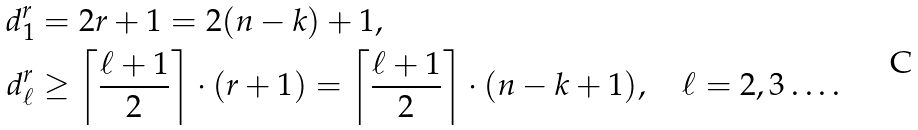<formula> <loc_0><loc_0><loc_500><loc_500>d ^ { r } _ { 1 } & = 2 r + 1 = 2 ( n - k ) + 1 , \\ d ^ { r } _ { \ell } & \geq \left \lceil \frac { \ell + 1 } { 2 } \right \rceil \cdot ( r + 1 ) = \left \lceil \frac { \ell + 1 } { 2 } \right \rceil \cdot ( n - k + 1 ) , \quad \ell = 2 , 3 \dots .</formula> 